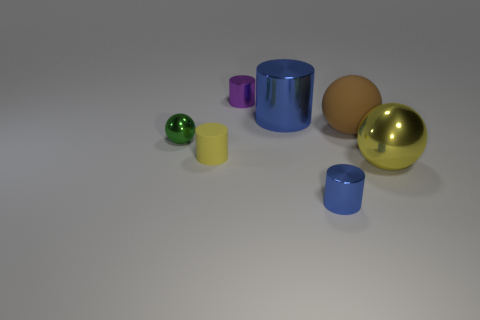Subtract all tiny cylinders. How many cylinders are left? 1 Subtract all purple cylinders. How many cylinders are left? 3 Subtract all green cubes. How many blue cylinders are left? 2 Subtract 1 balls. How many balls are left? 2 Add 1 tiny green blocks. How many objects exist? 8 Subtract all blue balls. Subtract all brown cylinders. How many balls are left? 3 Subtract all cylinders. How many objects are left? 3 Subtract all large cyan cubes. Subtract all tiny yellow things. How many objects are left? 6 Add 4 brown things. How many brown things are left? 5 Add 4 tiny purple matte spheres. How many tiny purple matte spheres exist? 4 